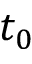<formula> <loc_0><loc_0><loc_500><loc_500>t _ { 0 }</formula> 